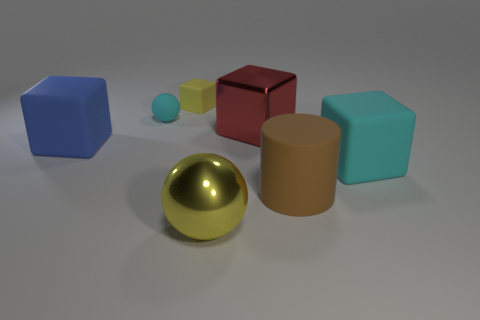How many things are large yellow objects on the right side of the big blue rubber thing or green matte objects?
Ensure brevity in your answer.  1. Are there any other tiny things that have the same shape as the small cyan thing?
Provide a short and direct response. No. The large thing that is behind the big cube that is on the left side of the red metallic thing is what shape?
Your answer should be compact. Cube. What number of cylinders are either blue rubber things or large cyan rubber objects?
Ensure brevity in your answer.  0. There is a large ball that is the same color as the tiny block; what is its material?
Ensure brevity in your answer.  Metal. There is a cyan object that is behind the big cyan matte thing; does it have the same shape as the big rubber object that is in front of the big cyan object?
Your answer should be compact. No. What is the color of the matte thing that is both in front of the cyan sphere and left of the yellow rubber cube?
Keep it short and to the point. Blue. There is a rubber cylinder; is it the same color as the matte cube on the right side of the tiny yellow rubber thing?
Your answer should be compact. No. What is the size of the matte object that is both behind the big blue object and in front of the small yellow rubber object?
Make the answer very short. Small. How many other objects are there of the same color as the tiny rubber cube?
Make the answer very short. 1. 